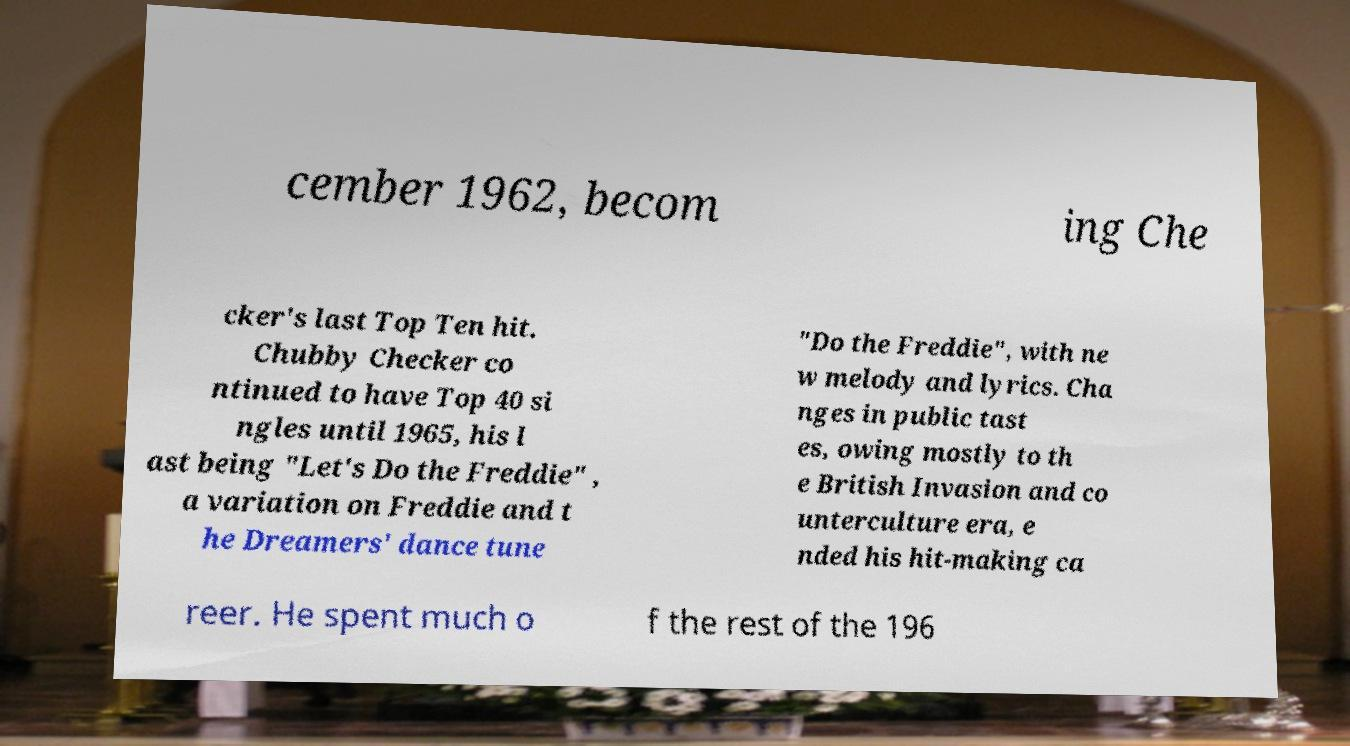Can you accurately transcribe the text from the provided image for me? cember 1962, becom ing Che cker's last Top Ten hit. Chubby Checker co ntinued to have Top 40 si ngles until 1965, his l ast being "Let's Do the Freddie" , a variation on Freddie and t he Dreamers' dance tune "Do the Freddie", with ne w melody and lyrics. Cha nges in public tast es, owing mostly to th e British Invasion and co unterculture era, e nded his hit-making ca reer. He spent much o f the rest of the 196 